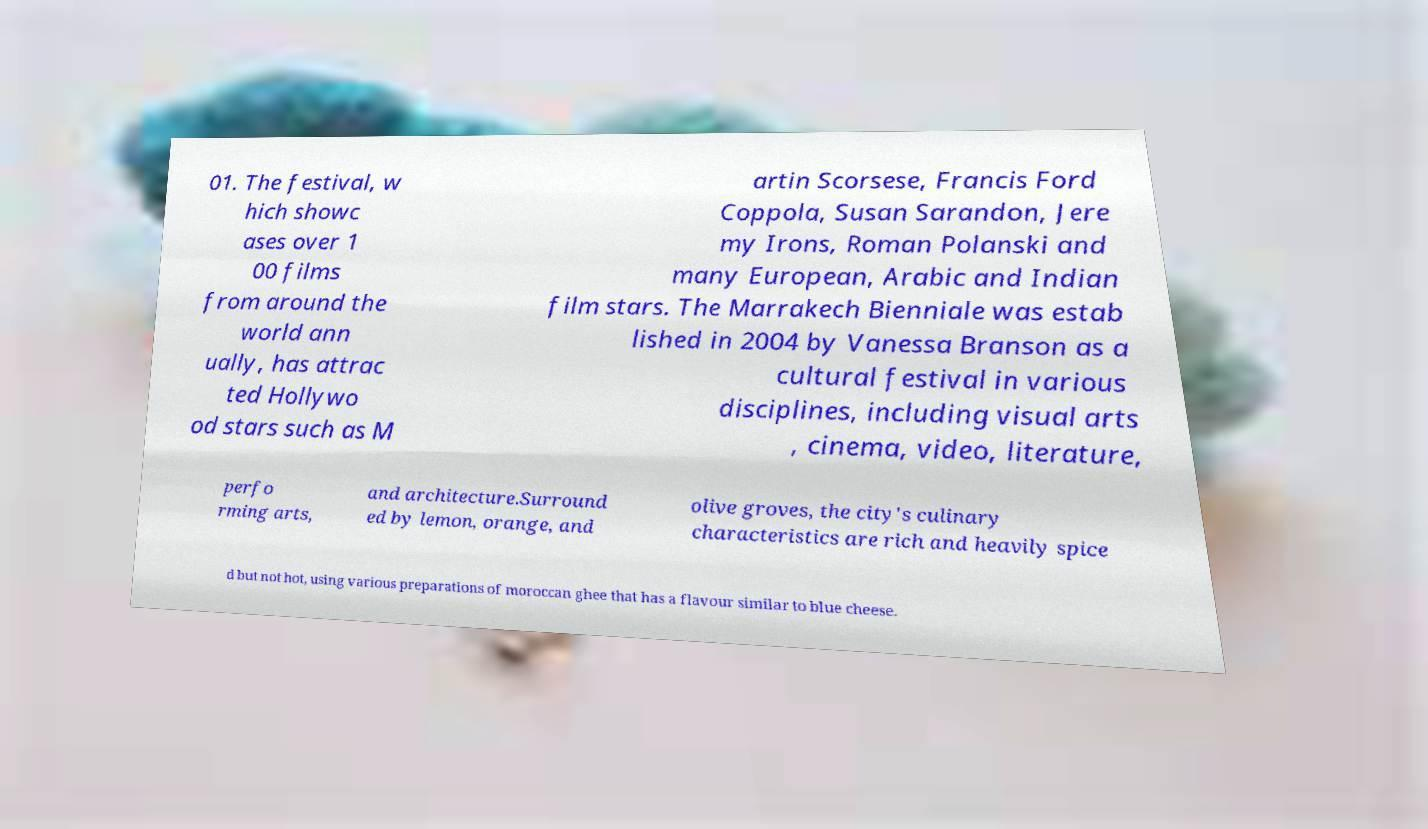There's text embedded in this image that I need extracted. Can you transcribe it verbatim? 01. The festival, w hich showc ases over 1 00 films from around the world ann ually, has attrac ted Hollywo od stars such as M artin Scorsese, Francis Ford Coppola, Susan Sarandon, Jere my Irons, Roman Polanski and many European, Arabic and Indian film stars. The Marrakech Bienniale was estab lished in 2004 by Vanessa Branson as a cultural festival in various disciplines, including visual arts , cinema, video, literature, perfo rming arts, and architecture.Surround ed by lemon, orange, and olive groves, the city's culinary characteristics are rich and heavily spice d but not hot, using various preparations of moroccan ghee that has a flavour similar to blue cheese. 